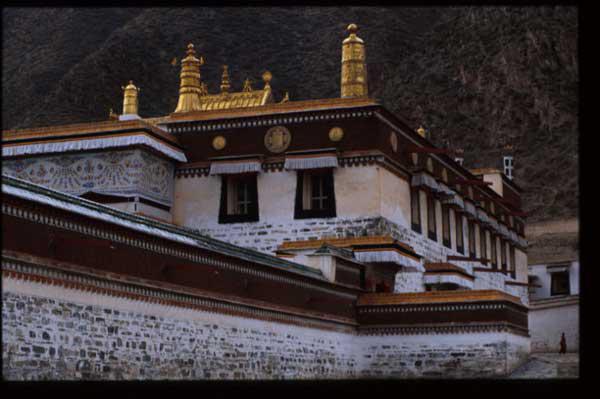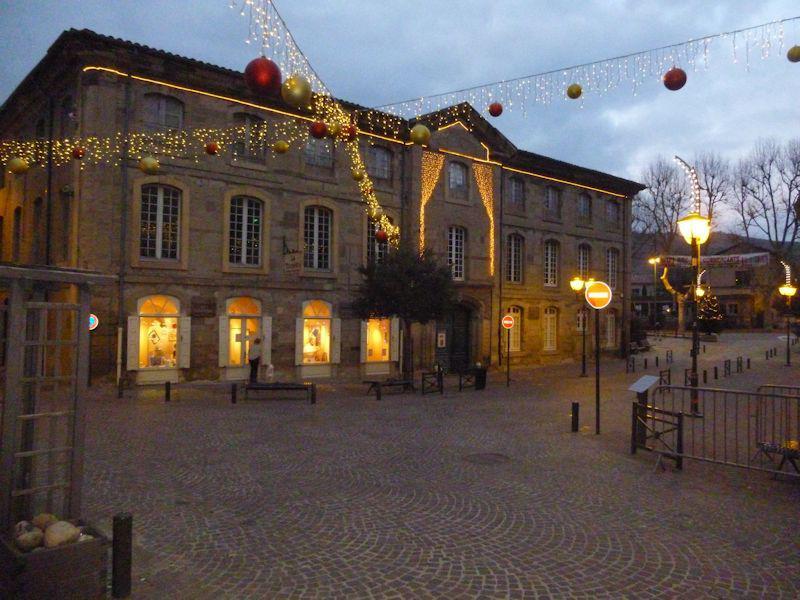The first image is the image on the left, the second image is the image on the right. For the images displayed, is the sentence "At least one image shows a building with a cone-shape atop a cylinder." factually correct? Answer yes or no. No. The first image is the image on the left, the second image is the image on the right. Analyze the images presented: Is the assertion "There is a conical roof in one of the images." valid? Answer yes or no. No. 